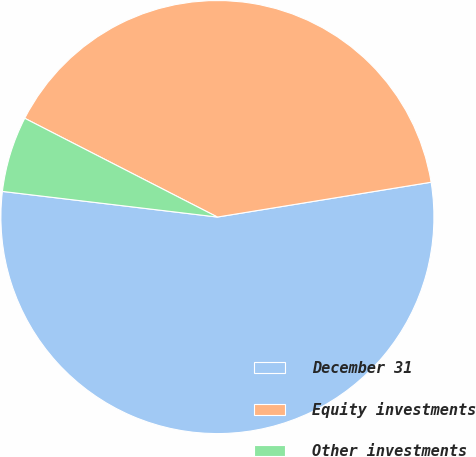Convert chart. <chart><loc_0><loc_0><loc_500><loc_500><pie_chart><fcel>December 31<fcel>Equity investments<fcel>Other investments<nl><fcel>54.46%<fcel>39.89%<fcel>5.65%<nl></chart> 